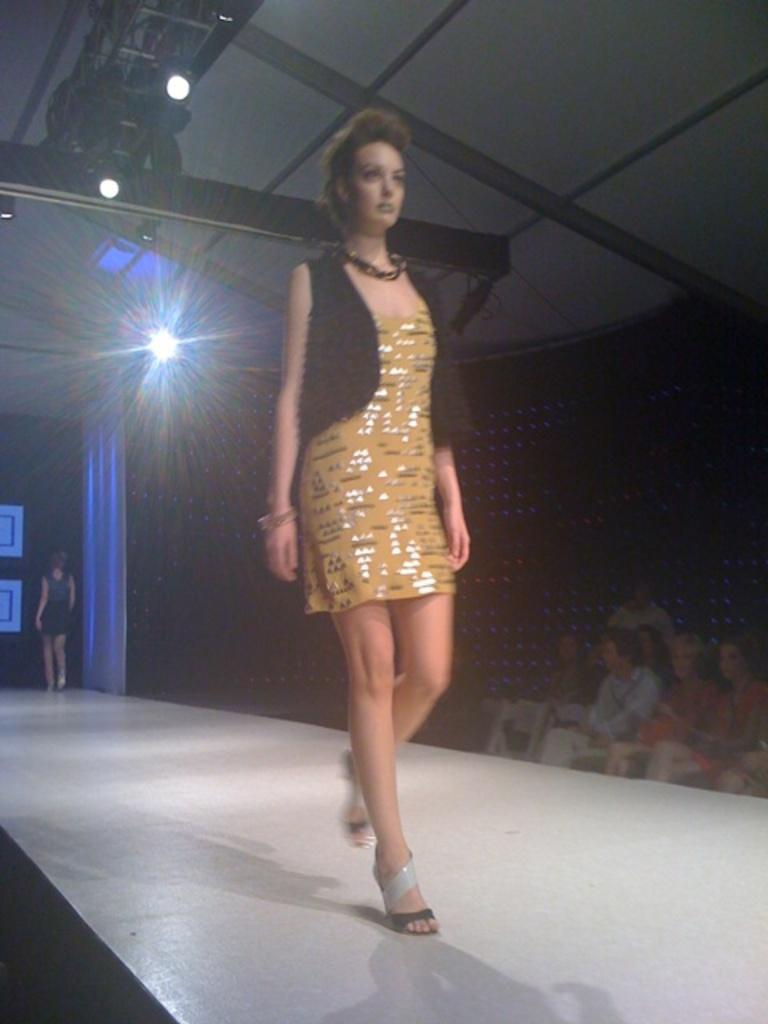Could you give a brief overview of what you see in this image? In this picture we can see a woman walking on the stage and in the background we can see lights,people. 